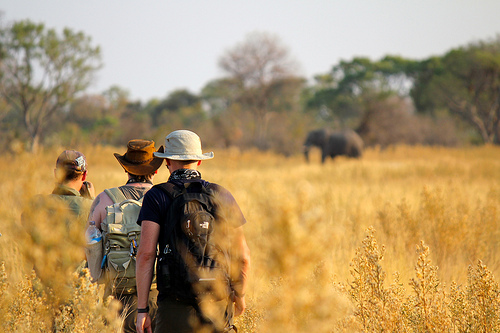Describe in detail what you think the backpack contains. The backpack likely contains a variety of essential items for the men's expedition. It might include water bottles and hydration packs to keep them hydrated, maps and GPS devices for navigation, a first aid kit for any medical emergencies, and perhaps some food and snacks to sustain them during their trek. Additionally, there could be binoculars and cameras for observing and documenting wildlife, research journals to record their findings, and possibly even camping gear like a compact tent and sleeping bag if they plan to stay out overnight. 